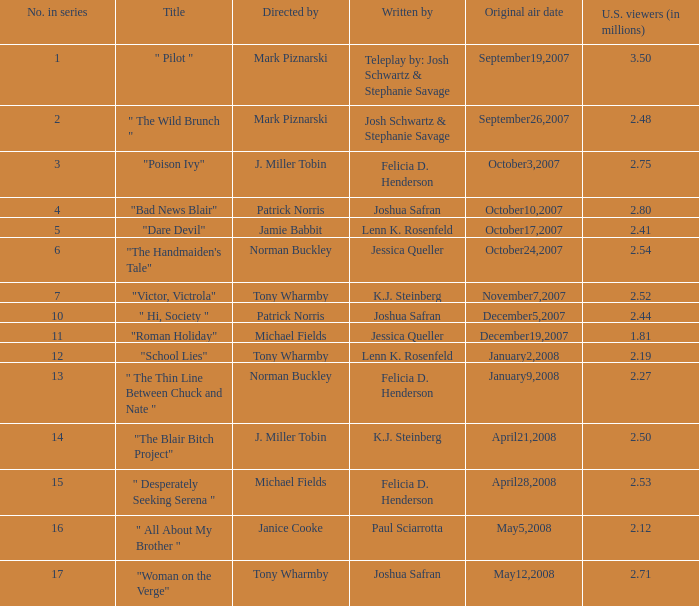Could you help me parse every detail presented in this table? {'header': ['No. in series', 'Title', 'Directed by', 'Written by', 'Original air date', 'U.S. viewers (in millions)'], 'rows': [['1', '" Pilot "', 'Mark Piznarski', 'Teleplay by: Josh Schwartz & Stephanie Savage', 'September19,2007', '3.50'], ['2', '" The Wild Brunch "', 'Mark Piznarski', 'Josh Schwartz & Stephanie Savage', 'September26,2007', '2.48'], ['3', '"Poison Ivy"', 'J. Miller Tobin', 'Felicia D. Henderson', 'October3,2007', '2.75'], ['4', '"Bad News Blair"', 'Patrick Norris', 'Joshua Safran', 'October10,2007', '2.80'], ['5', '"Dare Devil"', 'Jamie Babbit', 'Lenn K. Rosenfeld', 'October17,2007', '2.41'], ['6', '"The Handmaiden\'s Tale"', 'Norman Buckley', 'Jessica Queller', 'October24,2007', '2.54'], ['7', '"Victor, Victrola"', 'Tony Wharmby', 'K.J. Steinberg', 'November7,2007', '2.52'], ['10', '" Hi, Society "', 'Patrick Norris', 'Joshua Safran', 'December5,2007', '2.44'], ['11', '"Roman Holiday"', 'Michael Fields', 'Jessica Queller', 'December19,2007', '1.81'], ['12', '"School Lies"', 'Tony Wharmby', 'Lenn K. Rosenfeld', 'January2,2008', '2.19'], ['13', '" The Thin Line Between Chuck and Nate "', 'Norman Buckley', 'Felicia D. Henderson', 'January9,2008', '2.27'], ['14', '"The Blair Bitch Project"', 'J. Miller Tobin', 'K.J. Steinberg', 'April21,2008', '2.50'], ['15', '" Desperately Seeking Serena "', 'Michael Fields', 'Felicia D. Henderson', 'April28,2008', '2.53'], ['16', '" All About My Brother "', 'Janice Cooke', 'Paul Sciarrotta', 'May5,2008', '2.12'], ['17', '"Woman on the Verge"', 'Tony Wharmby', 'Joshua Safran', 'May12,2008', '2.71']]} How many u.s. viewers  (in millions) have "dare devil" as the title? 2.41. 